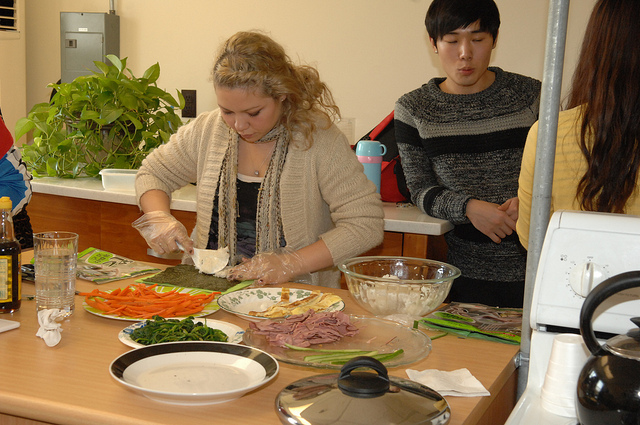<image>What type of design is on the plates? I am not sure what type of design is on the plates. It could be floral, border, line, or none. What type of design is on the plates? I am not sure what type of design is on the plates. It can be seen as floral, border, or pattern. 